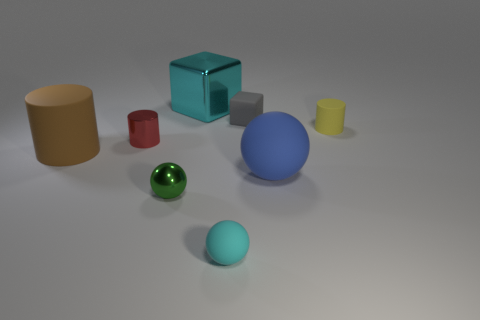Subtract all big cylinders. How many cylinders are left? 2 Add 2 small green metal objects. How many objects exist? 10 Subtract all cyan blocks. How many blocks are left? 1 Add 1 small brown spheres. How many small brown spheres exist? 1 Subtract 1 blue balls. How many objects are left? 7 Subtract all cylinders. How many objects are left? 5 Subtract 1 cylinders. How many cylinders are left? 2 Subtract all purple cylinders. Subtract all red cubes. How many cylinders are left? 3 Subtract all blue balls. How many yellow cylinders are left? 1 Subtract all red metallic things. Subtract all small shiny balls. How many objects are left? 6 